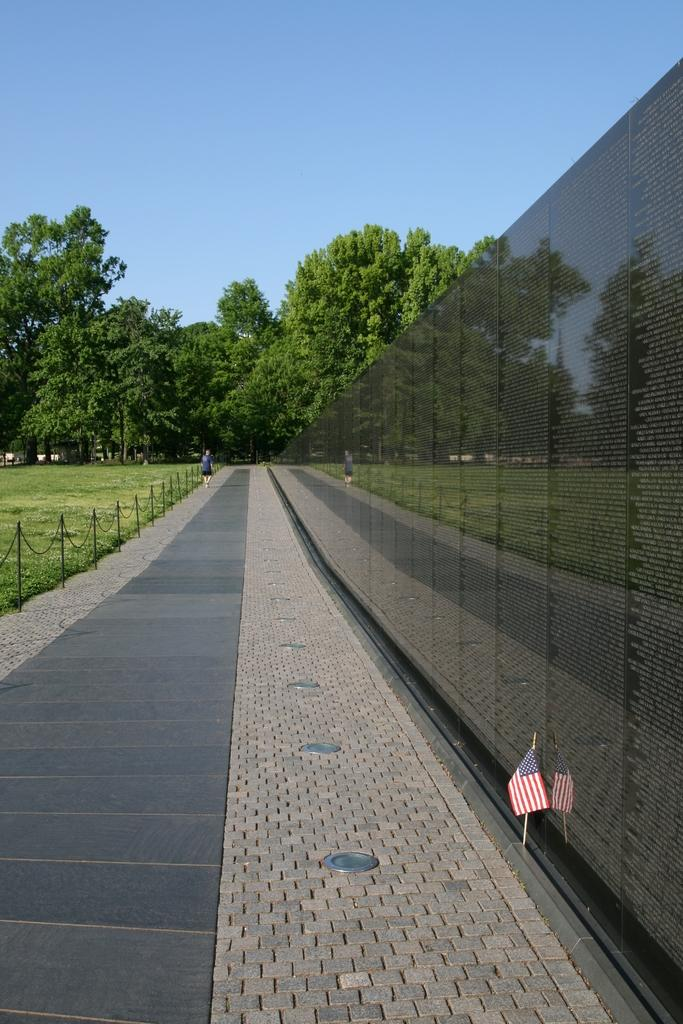What type of vegetation can be seen in the image? There are trees in the image. What structures are present in the image? There are poles in the image. What type of ground surface is visible in the image? There is grass in the image. What is attached to the poles in the image? There is a flag in the image. Who or what is present in the image? There is a person in the image. What is on the right side of the image? There is a wall on the right side of the image. What can be seen in the background of the image? The sky is visible in the background of the image. How does the person in the image clear their throat? There is no indication in the image of the person clearing their throat, so it cannot be determined from the image. 